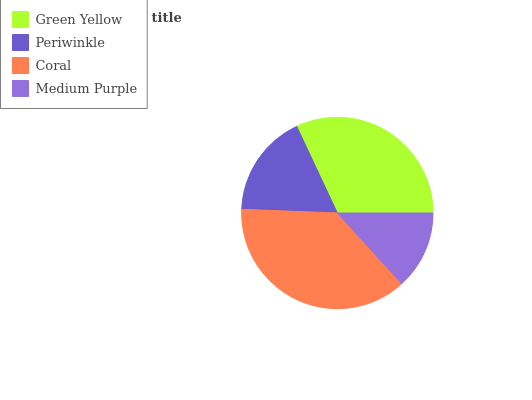Is Medium Purple the minimum?
Answer yes or no. Yes. Is Coral the maximum?
Answer yes or no. Yes. Is Periwinkle the minimum?
Answer yes or no. No. Is Periwinkle the maximum?
Answer yes or no. No. Is Green Yellow greater than Periwinkle?
Answer yes or no. Yes. Is Periwinkle less than Green Yellow?
Answer yes or no. Yes. Is Periwinkle greater than Green Yellow?
Answer yes or no. No. Is Green Yellow less than Periwinkle?
Answer yes or no. No. Is Green Yellow the high median?
Answer yes or no. Yes. Is Periwinkle the low median?
Answer yes or no. Yes. Is Medium Purple the high median?
Answer yes or no. No. Is Green Yellow the low median?
Answer yes or no. No. 